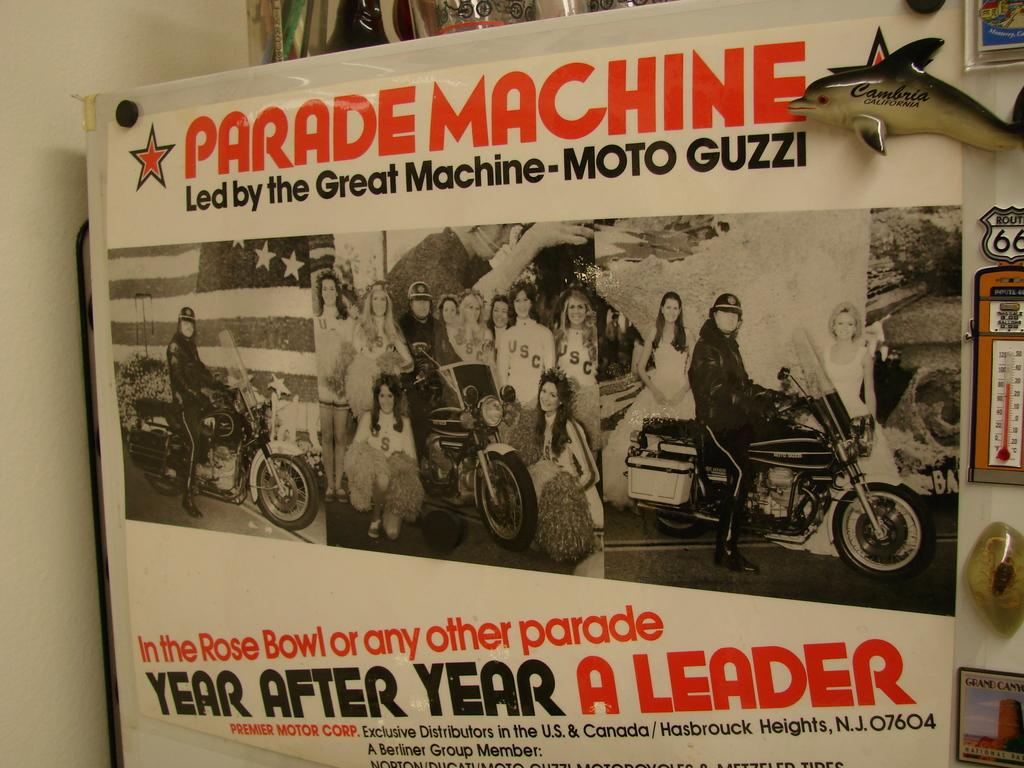<image>
Render a clear and concise summary of the photo. A white poster in black and orange writing that says "Parade Machine led by the Great Machine- Moto Guzzi." 